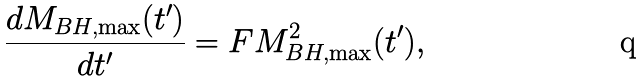<formula> <loc_0><loc_0><loc_500><loc_500>\frac { d M _ { B H , \max } ( t ^ { \prime } ) } { d t ^ { \prime } } = F M _ { B H , \max } ^ { 2 } ( t ^ { \prime } ) ,</formula> 